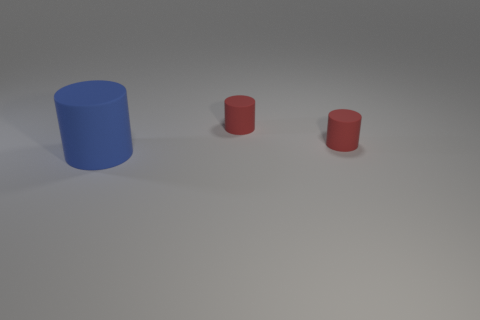Subtract all yellow spheres. How many red cylinders are left? 2 Add 3 big yellow spheres. How many objects exist? 6 Subtract all small red cylinders. How many cylinders are left? 1 Subtract 1 cylinders. How many cylinders are left? 2 Add 3 tiny things. How many tiny things are left? 5 Add 1 blue matte things. How many blue matte things exist? 2 Subtract 0 red blocks. How many objects are left? 3 Subtract all green cylinders. Subtract all yellow blocks. How many cylinders are left? 3 Subtract all red rubber cylinders. Subtract all big blue things. How many objects are left? 0 